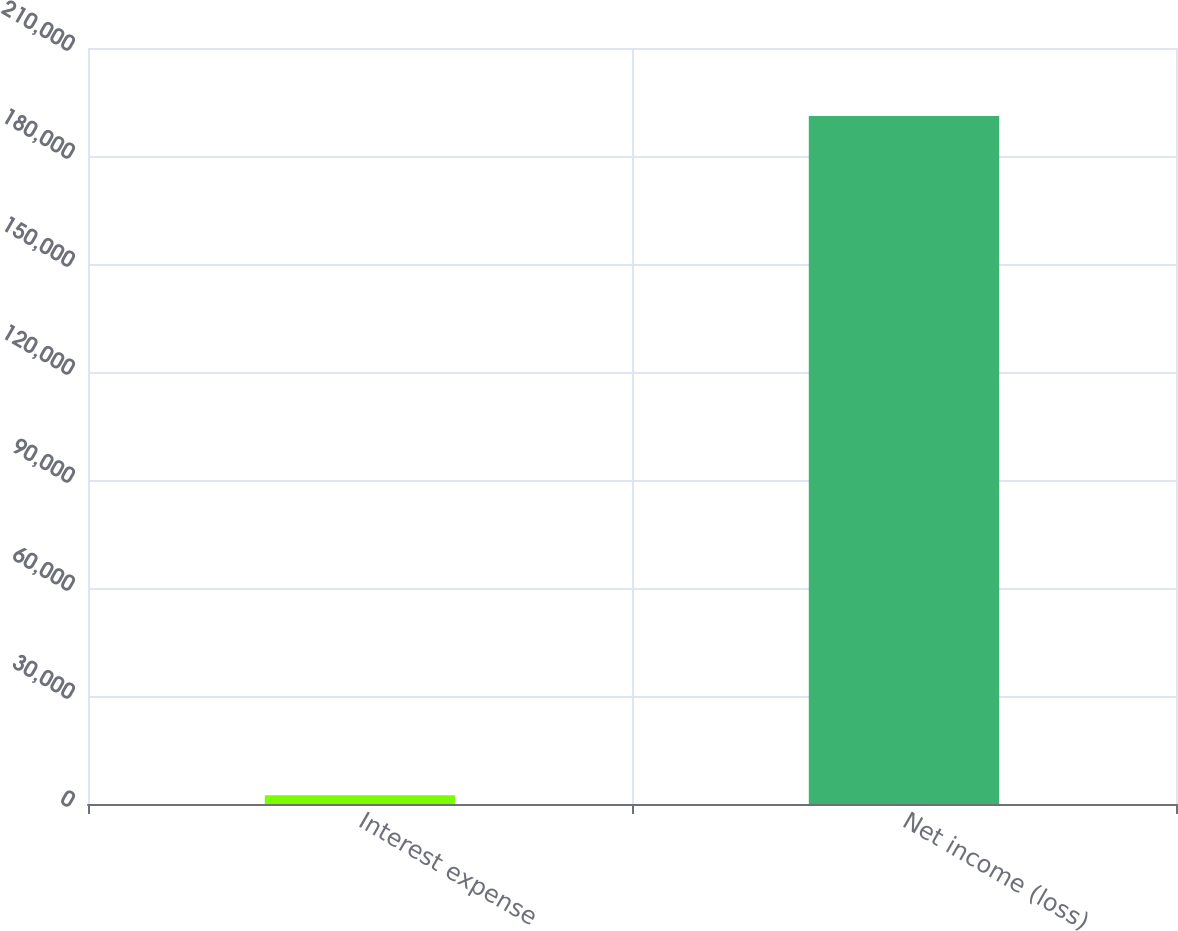<chart> <loc_0><loc_0><loc_500><loc_500><bar_chart><fcel>Interest expense<fcel>Net income (loss)<nl><fcel>2404<fcel>191105<nl></chart> 